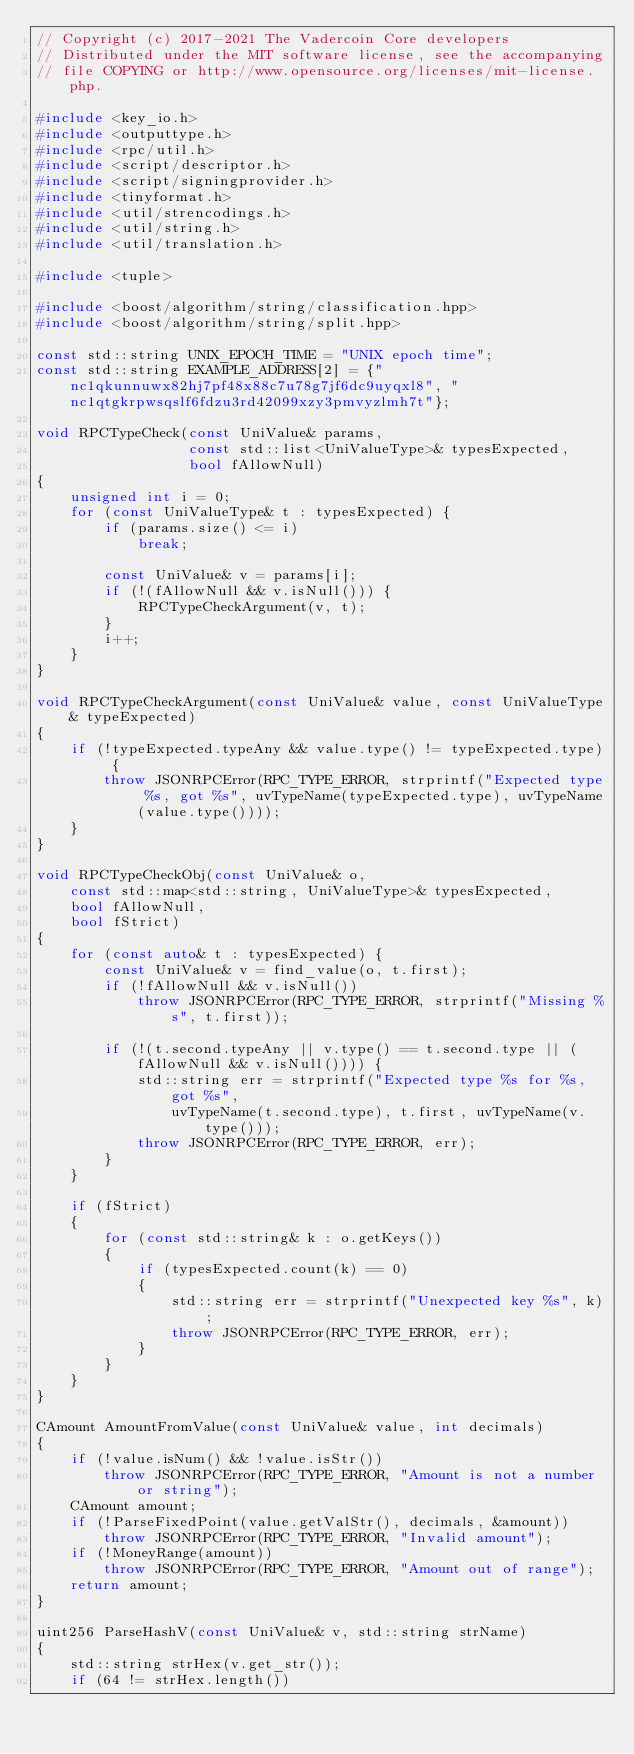Convert code to text. <code><loc_0><loc_0><loc_500><loc_500><_C++_>// Copyright (c) 2017-2021 The Vadercoin Core developers
// Distributed under the MIT software license, see the accompanying
// file COPYING or http://www.opensource.org/licenses/mit-license.php.

#include <key_io.h>
#include <outputtype.h>
#include <rpc/util.h>
#include <script/descriptor.h>
#include <script/signingprovider.h>
#include <tinyformat.h>
#include <util/strencodings.h>
#include <util/string.h>
#include <util/translation.h>

#include <tuple>

#include <boost/algorithm/string/classification.hpp>
#include <boost/algorithm/string/split.hpp>

const std::string UNIX_EPOCH_TIME = "UNIX epoch time";
const std::string EXAMPLE_ADDRESS[2] = {"nc1qkunnuwx82hj7pf48x88c7u78g7jf6dc9uyqxl8", "nc1qtgkrpwsqslf6fdzu3rd42099xzy3pmvyzlmh7t"};

void RPCTypeCheck(const UniValue& params,
                  const std::list<UniValueType>& typesExpected,
                  bool fAllowNull)
{
    unsigned int i = 0;
    for (const UniValueType& t : typesExpected) {
        if (params.size() <= i)
            break;

        const UniValue& v = params[i];
        if (!(fAllowNull && v.isNull())) {
            RPCTypeCheckArgument(v, t);
        }
        i++;
    }
}

void RPCTypeCheckArgument(const UniValue& value, const UniValueType& typeExpected)
{
    if (!typeExpected.typeAny && value.type() != typeExpected.type) {
        throw JSONRPCError(RPC_TYPE_ERROR, strprintf("Expected type %s, got %s", uvTypeName(typeExpected.type), uvTypeName(value.type())));
    }
}

void RPCTypeCheckObj(const UniValue& o,
    const std::map<std::string, UniValueType>& typesExpected,
    bool fAllowNull,
    bool fStrict)
{
    for (const auto& t : typesExpected) {
        const UniValue& v = find_value(o, t.first);
        if (!fAllowNull && v.isNull())
            throw JSONRPCError(RPC_TYPE_ERROR, strprintf("Missing %s", t.first));

        if (!(t.second.typeAny || v.type() == t.second.type || (fAllowNull && v.isNull()))) {
            std::string err = strprintf("Expected type %s for %s, got %s",
                uvTypeName(t.second.type), t.first, uvTypeName(v.type()));
            throw JSONRPCError(RPC_TYPE_ERROR, err);
        }
    }

    if (fStrict)
    {
        for (const std::string& k : o.getKeys())
        {
            if (typesExpected.count(k) == 0)
            {
                std::string err = strprintf("Unexpected key %s", k);
                throw JSONRPCError(RPC_TYPE_ERROR, err);
            }
        }
    }
}

CAmount AmountFromValue(const UniValue& value, int decimals)
{
    if (!value.isNum() && !value.isStr())
        throw JSONRPCError(RPC_TYPE_ERROR, "Amount is not a number or string");
    CAmount amount;
    if (!ParseFixedPoint(value.getValStr(), decimals, &amount))
        throw JSONRPCError(RPC_TYPE_ERROR, "Invalid amount");
    if (!MoneyRange(amount))
        throw JSONRPCError(RPC_TYPE_ERROR, "Amount out of range");
    return amount;
}

uint256 ParseHashV(const UniValue& v, std::string strName)
{
    std::string strHex(v.get_str());
    if (64 != strHex.length())</code> 